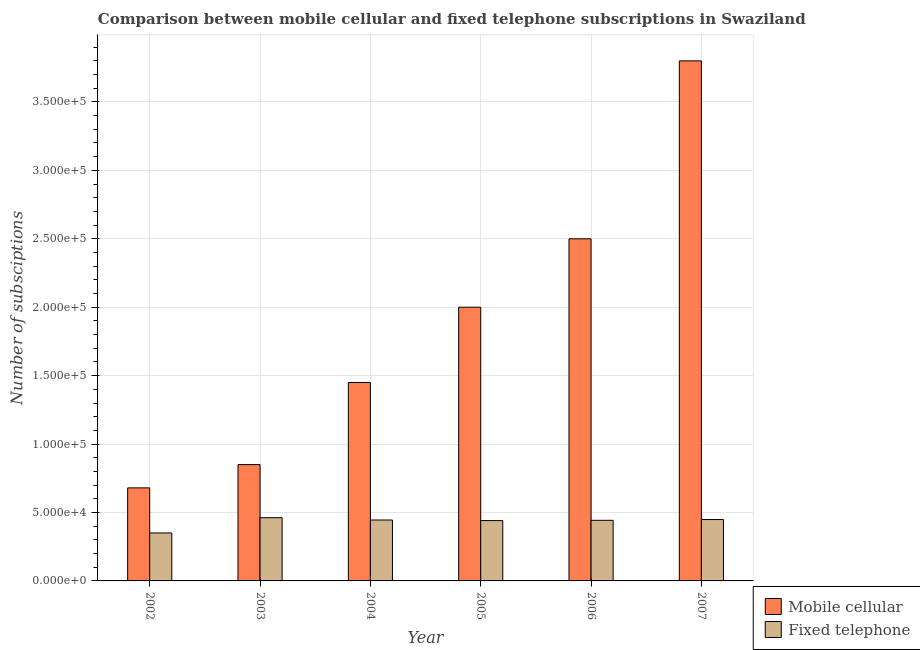How many different coloured bars are there?
Your answer should be very brief. 2. Are the number of bars per tick equal to the number of legend labels?
Offer a very short reply. Yes. Are the number of bars on each tick of the X-axis equal?
Your answer should be very brief. Yes. In how many cases, is the number of bars for a given year not equal to the number of legend labels?
Offer a terse response. 0. What is the number of mobile cellular subscriptions in 2006?
Offer a terse response. 2.50e+05. Across all years, what is the maximum number of mobile cellular subscriptions?
Give a very brief answer. 3.80e+05. Across all years, what is the minimum number of fixed telephone subscriptions?
Give a very brief answer. 3.51e+04. In which year was the number of mobile cellular subscriptions minimum?
Offer a very short reply. 2002. What is the total number of mobile cellular subscriptions in the graph?
Your response must be concise. 1.13e+06. What is the difference between the number of fixed telephone subscriptions in 2004 and that in 2006?
Your response must be concise. 220. What is the difference between the number of mobile cellular subscriptions in 2004 and the number of fixed telephone subscriptions in 2007?
Your answer should be compact. -2.35e+05. What is the average number of fixed telephone subscriptions per year?
Provide a short and direct response. 4.32e+04. What is the ratio of the number of mobile cellular subscriptions in 2004 to that in 2007?
Give a very brief answer. 0.38. Is the number of fixed telephone subscriptions in 2004 less than that in 2007?
Provide a succinct answer. Yes. What is the difference between the highest and the second highest number of fixed telephone subscriptions?
Your answer should be very brief. 1350. What is the difference between the highest and the lowest number of fixed telephone subscriptions?
Make the answer very short. 1.11e+04. Is the sum of the number of mobile cellular subscriptions in 2003 and 2005 greater than the maximum number of fixed telephone subscriptions across all years?
Your answer should be very brief. No. What does the 1st bar from the left in 2004 represents?
Your response must be concise. Mobile cellular. What does the 2nd bar from the right in 2006 represents?
Ensure brevity in your answer.  Mobile cellular. How many bars are there?
Provide a short and direct response. 12. Are all the bars in the graph horizontal?
Provide a succinct answer. No. Are the values on the major ticks of Y-axis written in scientific E-notation?
Your answer should be very brief. Yes. Does the graph contain any zero values?
Your answer should be compact. No. Does the graph contain grids?
Provide a succinct answer. Yes. What is the title of the graph?
Your answer should be very brief. Comparison between mobile cellular and fixed telephone subscriptions in Swaziland. What is the label or title of the X-axis?
Offer a very short reply. Year. What is the label or title of the Y-axis?
Your answer should be very brief. Number of subsciptions. What is the Number of subsciptions in Mobile cellular in 2002?
Your answer should be compact. 6.80e+04. What is the Number of subsciptions of Fixed telephone in 2002?
Make the answer very short. 3.51e+04. What is the Number of subsciptions of Mobile cellular in 2003?
Make the answer very short. 8.50e+04. What is the Number of subsciptions in Fixed telephone in 2003?
Offer a very short reply. 4.62e+04. What is the Number of subsciptions in Mobile cellular in 2004?
Your answer should be very brief. 1.45e+05. What is the Number of subsciptions in Fixed telephone in 2004?
Offer a terse response. 4.45e+04. What is the Number of subsciptions in Mobile cellular in 2005?
Make the answer very short. 2.00e+05. What is the Number of subsciptions of Fixed telephone in 2005?
Offer a terse response. 4.41e+04. What is the Number of subsciptions of Mobile cellular in 2006?
Your answer should be very brief. 2.50e+05. What is the Number of subsciptions of Fixed telephone in 2006?
Make the answer very short. 4.43e+04. What is the Number of subsciptions in Fixed telephone in 2007?
Make the answer very short. 4.48e+04. Across all years, what is the maximum Number of subsciptions in Mobile cellular?
Offer a terse response. 3.80e+05. Across all years, what is the maximum Number of subsciptions in Fixed telephone?
Your answer should be compact. 4.62e+04. Across all years, what is the minimum Number of subsciptions of Mobile cellular?
Keep it short and to the point. 6.80e+04. Across all years, what is the minimum Number of subsciptions of Fixed telephone?
Give a very brief answer. 3.51e+04. What is the total Number of subsciptions in Mobile cellular in the graph?
Give a very brief answer. 1.13e+06. What is the total Number of subsciptions in Fixed telephone in the graph?
Keep it short and to the point. 2.59e+05. What is the difference between the Number of subsciptions in Mobile cellular in 2002 and that in 2003?
Provide a succinct answer. -1.70e+04. What is the difference between the Number of subsciptions in Fixed telephone in 2002 and that in 2003?
Give a very brief answer. -1.11e+04. What is the difference between the Number of subsciptions of Mobile cellular in 2002 and that in 2004?
Provide a short and direct response. -7.70e+04. What is the difference between the Number of subsciptions in Fixed telephone in 2002 and that in 2004?
Ensure brevity in your answer.  -9447. What is the difference between the Number of subsciptions in Mobile cellular in 2002 and that in 2005?
Ensure brevity in your answer.  -1.32e+05. What is the difference between the Number of subsciptions in Fixed telephone in 2002 and that in 2005?
Provide a succinct answer. -9031. What is the difference between the Number of subsciptions of Mobile cellular in 2002 and that in 2006?
Your answer should be compact. -1.82e+05. What is the difference between the Number of subsciptions in Fixed telephone in 2002 and that in 2006?
Keep it short and to the point. -9227. What is the difference between the Number of subsciptions of Mobile cellular in 2002 and that in 2007?
Keep it short and to the point. -3.12e+05. What is the difference between the Number of subsciptions in Fixed telephone in 2002 and that in 2007?
Keep it short and to the point. -9789. What is the difference between the Number of subsciptions in Mobile cellular in 2003 and that in 2004?
Make the answer very short. -6.00e+04. What is the difference between the Number of subsciptions of Fixed telephone in 2003 and that in 2004?
Offer a very short reply. 1692. What is the difference between the Number of subsciptions of Mobile cellular in 2003 and that in 2005?
Provide a succinct answer. -1.15e+05. What is the difference between the Number of subsciptions of Fixed telephone in 2003 and that in 2005?
Make the answer very short. 2108. What is the difference between the Number of subsciptions in Mobile cellular in 2003 and that in 2006?
Your answer should be compact. -1.65e+05. What is the difference between the Number of subsciptions of Fixed telephone in 2003 and that in 2006?
Keep it short and to the point. 1912. What is the difference between the Number of subsciptions in Mobile cellular in 2003 and that in 2007?
Your answer should be very brief. -2.95e+05. What is the difference between the Number of subsciptions of Fixed telephone in 2003 and that in 2007?
Make the answer very short. 1350. What is the difference between the Number of subsciptions in Mobile cellular in 2004 and that in 2005?
Offer a terse response. -5.50e+04. What is the difference between the Number of subsciptions of Fixed telephone in 2004 and that in 2005?
Keep it short and to the point. 416. What is the difference between the Number of subsciptions in Mobile cellular in 2004 and that in 2006?
Provide a short and direct response. -1.05e+05. What is the difference between the Number of subsciptions of Fixed telephone in 2004 and that in 2006?
Offer a terse response. 220. What is the difference between the Number of subsciptions in Mobile cellular in 2004 and that in 2007?
Give a very brief answer. -2.35e+05. What is the difference between the Number of subsciptions in Fixed telephone in 2004 and that in 2007?
Keep it short and to the point. -342. What is the difference between the Number of subsciptions of Fixed telephone in 2005 and that in 2006?
Provide a succinct answer. -196. What is the difference between the Number of subsciptions of Mobile cellular in 2005 and that in 2007?
Your answer should be compact. -1.80e+05. What is the difference between the Number of subsciptions in Fixed telephone in 2005 and that in 2007?
Your response must be concise. -758. What is the difference between the Number of subsciptions in Mobile cellular in 2006 and that in 2007?
Keep it short and to the point. -1.30e+05. What is the difference between the Number of subsciptions in Fixed telephone in 2006 and that in 2007?
Your answer should be compact. -562. What is the difference between the Number of subsciptions of Mobile cellular in 2002 and the Number of subsciptions of Fixed telephone in 2003?
Offer a very short reply. 2.18e+04. What is the difference between the Number of subsciptions in Mobile cellular in 2002 and the Number of subsciptions in Fixed telephone in 2004?
Your answer should be compact. 2.35e+04. What is the difference between the Number of subsciptions of Mobile cellular in 2002 and the Number of subsciptions of Fixed telephone in 2005?
Your answer should be very brief. 2.39e+04. What is the difference between the Number of subsciptions in Mobile cellular in 2002 and the Number of subsciptions in Fixed telephone in 2006?
Your answer should be compact. 2.37e+04. What is the difference between the Number of subsciptions of Mobile cellular in 2002 and the Number of subsciptions of Fixed telephone in 2007?
Ensure brevity in your answer.  2.32e+04. What is the difference between the Number of subsciptions of Mobile cellular in 2003 and the Number of subsciptions of Fixed telephone in 2004?
Give a very brief answer. 4.05e+04. What is the difference between the Number of subsciptions of Mobile cellular in 2003 and the Number of subsciptions of Fixed telephone in 2005?
Offer a very short reply. 4.09e+04. What is the difference between the Number of subsciptions of Mobile cellular in 2003 and the Number of subsciptions of Fixed telephone in 2006?
Your response must be concise. 4.07e+04. What is the difference between the Number of subsciptions of Mobile cellular in 2003 and the Number of subsciptions of Fixed telephone in 2007?
Offer a very short reply. 4.02e+04. What is the difference between the Number of subsciptions in Mobile cellular in 2004 and the Number of subsciptions in Fixed telephone in 2005?
Offer a terse response. 1.01e+05. What is the difference between the Number of subsciptions in Mobile cellular in 2004 and the Number of subsciptions in Fixed telephone in 2006?
Provide a short and direct response. 1.01e+05. What is the difference between the Number of subsciptions in Mobile cellular in 2004 and the Number of subsciptions in Fixed telephone in 2007?
Provide a short and direct response. 1.00e+05. What is the difference between the Number of subsciptions of Mobile cellular in 2005 and the Number of subsciptions of Fixed telephone in 2006?
Your answer should be very brief. 1.56e+05. What is the difference between the Number of subsciptions of Mobile cellular in 2005 and the Number of subsciptions of Fixed telephone in 2007?
Provide a short and direct response. 1.55e+05. What is the difference between the Number of subsciptions in Mobile cellular in 2006 and the Number of subsciptions in Fixed telephone in 2007?
Your response must be concise. 2.05e+05. What is the average Number of subsciptions in Mobile cellular per year?
Provide a short and direct response. 1.88e+05. What is the average Number of subsciptions in Fixed telephone per year?
Your response must be concise. 4.32e+04. In the year 2002, what is the difference between the Number of subsciptions of Mobile cellular and Number of subsciptions of Fixed telephone?
Offer a terse response. 3.29e+04. In the year 2003, what is the difference between the Number of subsciptions in Mobile cellular and Number of subsciptions in Fixed telephone?
Your answer should be very brief. 3.88e+04. In the year 2004, what is the difference between the Number of subsciptions in Mobile cellular and Number of subsciptions in Fixed telephone?
Provide a succinct answer. 1.00e+05. In the year 2005, what is the difference between the Number of subsciptions of Mobile cellular and Number of subsciptions of Fixed telephone?
Your answer should be compact. 1.56e+05. In the year 2006, what is the difference between the Number of subsciptions in Mobile cellular and Number of subsciptions in Fixed telephone?
Make the answer very short. 2.06e+05. In the year 2007, what is the difference between the Number of subsciptions in Mobile cellular and Number of subsciptions in Fixed telephone?
Your answer should be compact. 3.35e+05. What is the ratio of the Number of subsciptions in Fixed telephone in 2002 to that in 2003?
Your answer should be very brief. 0.76. What is the ratio of the Number of subsciptions in Mobile cellular in 2002 to that in 2004?
Your answer should be very brief. 0.47. What is the ratio of the Number of subsciptions of Fixed telephone in 2002 to that in 2004?
Your answer should be very brief. 0.79. What is the ratio of the Number of subsciptions of Mobile cellular in 2002 to that in 2005?
Ensure brevity in your answer.  0.34. What is the ratio of the Number of subsciptions of Fixed telephone in 2002 to that in 2005?
Provide a short and direct response. 0.8. What is the ratio of the Number of subsciptions in Mobile cellular in 2002 to that in 2006?
Your response must be concise. 0.27. What is the ratio of the Number of subsciptions in Fixed telephone in 2002 to that in 2006?
Offer a very short reply. 0.79. What is the ratio of the Number of subsciptions in Mobile cellular in 2002 to that in 2007?
Provide a short and direct response. 0.18. What is the ratio of the Number of subsciptions in Fixed telephone in 2002 to that in 2007?
Ensure brevity in your answer.  0.78. What is the ratio of the Number of subsciptions of Mobile cellular in 2003 to that in 2004?
Give a very brief answer. 0.59. What is the ratio of the Number of subsciptions of Fixed telephone in 2003 to that in 2004?
Keep it short and to the point. 1.04. What is the ratio of the Number of subsciptions of Mobile cellular in 2003 to that in 2005?
Offer a terse response. 0.42. What is the ratio of the Number of subsciptions in Fixed telephone in 2003 to that in 2005?
Offer a terse response. 1.05. What is the ratio of the Number of subsciptions in Mobile cellular in 2003 to that in 2006?
Ensure brevity in your answer.  0.34. What is the ratio of the Number of subsciptions in Fixed telephone in 2003 to that in 2006?
Keep it short and to the point. 1.04. What is the ratio of the Number of subsciptions in Mobile cellular in 2003 to that in 2007?
Offer a very short reply. 0.22. What is the ratio of the Number of subsciptions of Fixed telephone in 2003 to that in 2007?
Keep it short and to the point. 1.03. What is the ratio of the Number of subsciptions in Mobile cellular in 2004 to that in 2005?
Your response must be concise. 0.72. What is the ratio of the Number of subsciptions of Fixed telephone in 2004 to that in 2005?
Your answer should be very brief. 1.01. What is the ratio of the Number of subsciptions in Mobile cellular in 2004 to that in 2006?
Make the answer very short. 0.58. What is the ratio of the Number of subsciptions in Fixed telephone in 2004 to that in 2006?
Ensure brevity in your answer.  1. What is the ratio of the Number of subsciptions of Mobile cellular in 2004 to that in 2007?
Provide a short and direct response. 0.38. What is the ratio of the Number of subsciptions in Fixed telephone in 2004 to that in 2007?
Provide a succinct answer. 0.99. What is the ratio of the Number of subsciptions in Mobile cellular in 2005 to that in 2007?
Your response must be concise. 0.53. What is the ratio of the Number of subsciptions in Fixed telephone in 2005 to that in 2007?
Provide a succinct answer. 0.98. What is the ratio of the Number of subsciptions of Mobile cellular in 2006 to that in 2007?
Provide a short and direct response. 0.66. What is the ratio of the Number of subsciptions of Fixed telephone in 2006 to that in 2007?
Offer a terse response. 0.99. What is the difference between the highest and the second highest Number of subsciptions in Mobile cellular?
Give a very brief answer. 1.30e+05. What is the difference between the highest and the second highest Number of subsciptions in Fixed telephone?
Give a very brief answer. 1350. What is the difference between the highest and the lowest Number of subsciptions in Mobile cellular?
Give a very brief answer. 3.12e+05. What is the difference between the highest and the lowest Number of subsciptions of Fixed telephone?
Provide a succinct answer. 1.11e+04. 